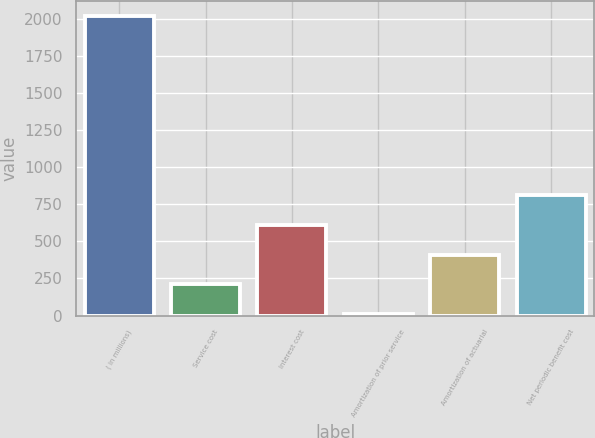Convert chart. <chart><loc_0><loc_0><loc_500><loc_500><bar_chart><fcel>( in millions)<fcel>Service cost<fcel>Interest cost<fcel>Amortization of prior service<fcel>Amortization of actuarial<fcel>Net periodic benefit cost<nl><fcel>2015<fcel>209.6<fcel>610.8<fcel>9<fcel>410.2<fcel>811.4<nl></chart> 